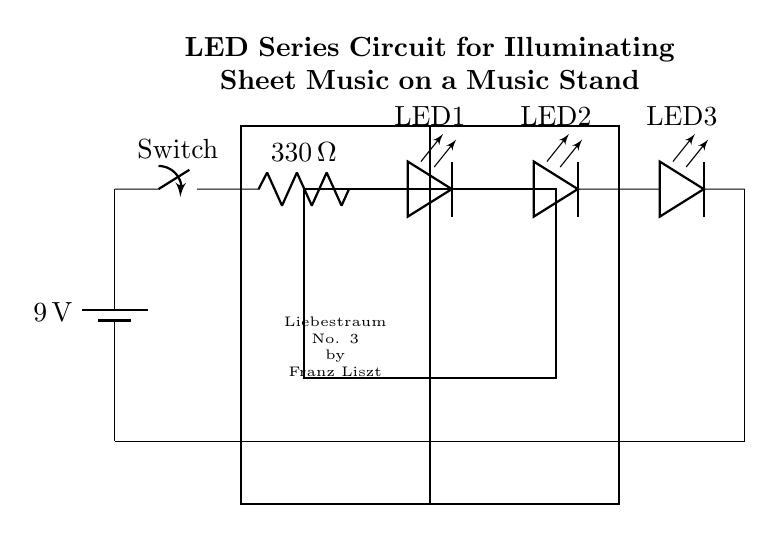What is the voltage of the battery? The voltage of the battery is indicated as 9 volts in the diagram, which is the power source for the circuit.
Answer: 9 volts How many LEDs are in the circuit? The circuit shows a total of three LEDs connected in series, which can be counted in the diagram.
Answer: Three What is the resistance value in the circuit? The circuit contains one resistor with a value of 330 ohms, as labeled in the diagram.
Answer: 330 ohms What does the switch do in this circuit? The switch controls the flow of electricity in the circuit, allowing the user to turn the LEDs on or off by opening or closing the circuit.
Answer: Control flow If the resistor is 330 ohms, what type of circuit configuration is shown? This circuit configuration is a series circuit, as all the components - the battery, switch, resistor, and LEDs - are connected in a single path for current flow.
Answer: Series circuit What is the purpose of the LEDs in this circuit? The purpose of the LEDs is to illuminate the sheet music placed on the music stand, providing necessary lighting for reading the music.
Answer: Illumination What is the labeled purpose of this circuit? The title above the circuit indicates that its purpose is to illuminate sheet music on a music stand, specifically showcasing a composition by Franz Liszt.
Answer: Illuminate sheet music 